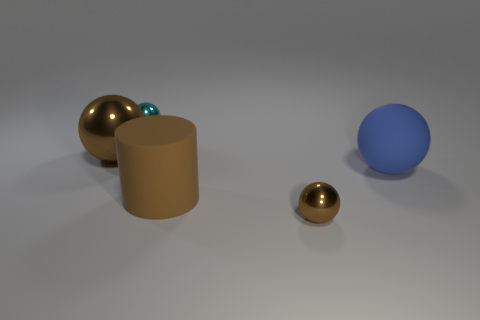What is the material of the object that is behind the large brown cylinder and to the right of the brown matte cylinder?
Provide a short and direct response. Rubber. Is the material of the small object that is right of the cyan object the same as the large brown object behind the blue rubber object?
Give a very brief answer. Yes. How big is the cyan shiny object?
Offer a terse response. Small. There is a cyan object that is the same shape as the large blue thing; what size is it?
Offer a terse response. Small. There is a blue rubber thing; what number of rubber cylinders are behind it?
Provide a short and direct response. 0. What is the color of the matte cylinder that is right of the brown metallic ball that is left of the brown cylinder?
Give a very brief answer. Brown. Is there any other thing that is the same shape as the blue thing?
Ensure brevity in your answer.  Yes. Are there an equal number of tiny cyan metal objects that are in front of the small brown thing and cyan metal balls on the left side of the tiny cyan shiny thing?
Provide a short and direct response. Yes. What number of cylinders are either large brown objects or tiny cyan metal objects?
Your answer should be very brief. 1. What number of other objects are there of the same material as the small brown thing?
Offer a very short reply. 2. 